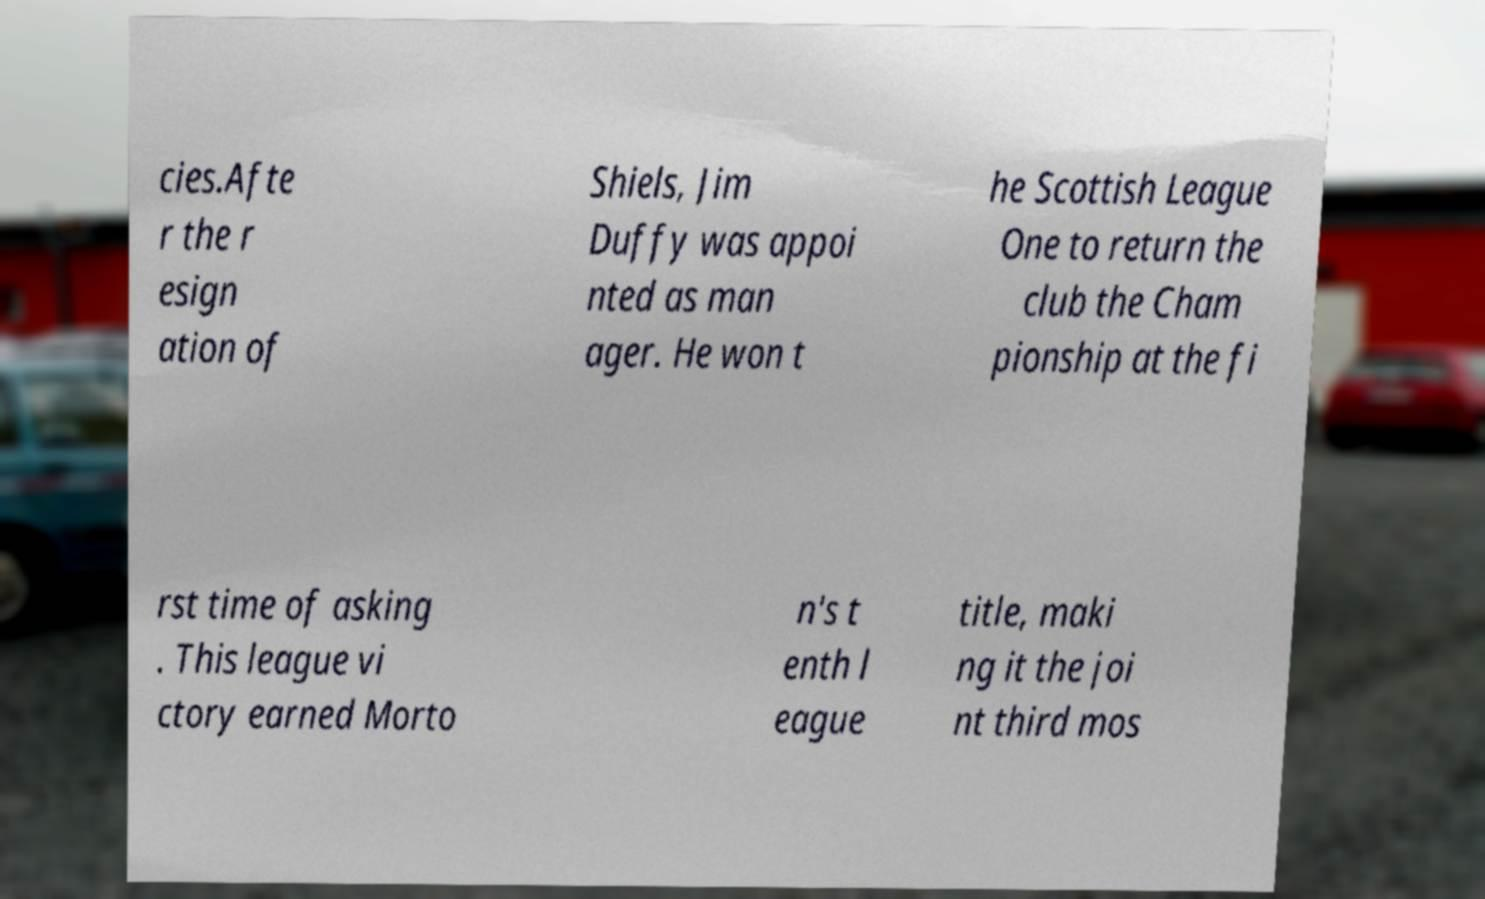What messages or text are displayed in this image? I need them in a readable, typed format. cies.Afte r the r esign ation of Shiels, Jim Duffy was appoi nted as man ager. He won t he Scottish League One to return the club the Cham pionship at the fi rst time of asking . This league vi ctory earned Morto n's t enth l eague title, maki ng it the joi nt third mos 